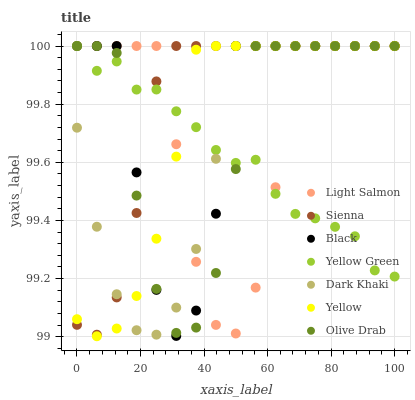Does Yellow Green have the minimum area under the curve?
Answer yes or no. Yes. Does Sienna have the maximum area under the curve?
Answer yes or no. Yes. Does Light Salmon have the minimum area under the curve?
Answer yes or no. No. Does Light Salmon have the maximum area under the curve?
Answer yes or no. No. Is Yellow the smoothest?
Answer yes or no. Yes. Is Black the roughest?
Answer yes or no. Yes. Is Light Salmon the smoothest?
Answer yes or no. No. Is Light Salmon the roughest?
Answer yes or no. No. Does Yellow have the lowest value?
Answer yes or no. Yes. Does Light Salmon have the lowest value?
Answer yes or no. No. Does Olive Drab have the highest value?
Answer yes or no. Yes. Does Light Salmon intersect Dark Khaki?
Answer yes or no. Yes. Is Light Salmon less than Dark Khaki?
Answer yes or no. No. Is Light Salmon greater than Dark Khaki?
Answer yes or no. No. 